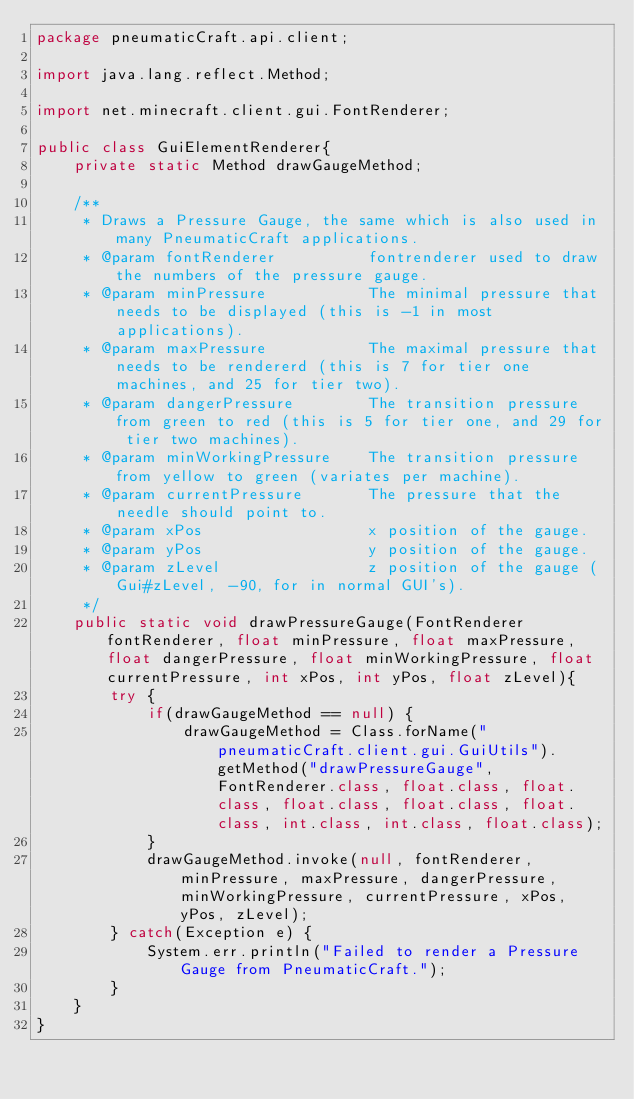<code> <loc_0><loc_0><loc_500><loc_500><_Java_>package pneumaticCraft.api.client;

import java.lang.reflect.Method;

import net.minecraft.client.gui.FontRenderer;

public class GuiElementRenderer{
    private static Method drawGaugeMethod;

    /**
     * Draws a Pressure Gauge, the same which is also used in many PneumaticCraft applications.
     * @param fontRenderer          fontrenderer used to draw the numbers of the pressure gauge.
     * @param minPressure           The minimal pressure that needs to be displayed (this is -1 in most applications).
     * @param maxPressure           The maximal pressure that needs to be rendererd (this is 7 for tier one machines, and 25 for tier two).
     * @param dangerPressure        The transition pressure from green to red (this is 5 for tier one, and 29 for tier two machines).
     * @param minWorkingPressure    The transition pressure from yellow to green (variates per machine).
     * @param currentPressure       The pressure that the needle should point to.
     * @param xPos                  x position of the gauge.
     * @param yPos                  y position of the gauge.
     * @param zLevel                z position of the gauge (Gui#zLevel, -90, for in normal GUI's).
     */
    public static void drawPressureGauge(FontRenderer fontRenderer, float minPressure, float maxPressure, float dangerPressure, float minWorkingPressure, float currentPressure, int xPos, int yPos, float zLevel){
        try {
            if(drawGaugeMethod == null) {
                drawGaugeMethod = Class.forName("pneumaticCraft.client.gui.GuiUtils").getMethod("drawPressureGauge", FontRenderer.class, float.class, float.class, float.class, float.class, float.class, int.class, int.class, float.class);
            }
            drawGaugeMethod.invoke(null, fontRenderer, minPressure, maxPressure, dangerPressure, minWorkingPressure, currentPressure, xPos, yPos, zLevel);
        } catch(Exception e) {
            System.err.println("Failed to render a Pressure Gauge from PneumaticCraft.");
        }
    }
}
</code> 